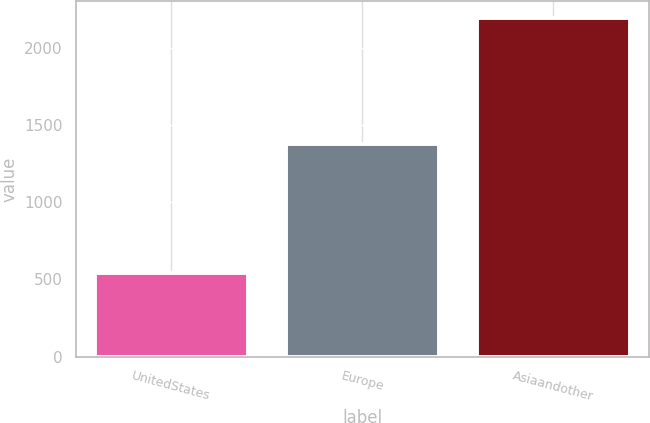Convert chart. <chart><loc_0><loc_0><loc_500><loc_500><bar_chart><fcel>UnitedStates<fcel>Europe<fcel>Asiaandother<nl><fcel>542<fcel>1379<fcel>2190<nl></chart> 